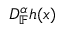Convert formula to latex. <formula><loc_0><loc_0><loc_500><loc_500>D _ { \mathbb { F } } ^ { \alpha } h ( x )</formula> 